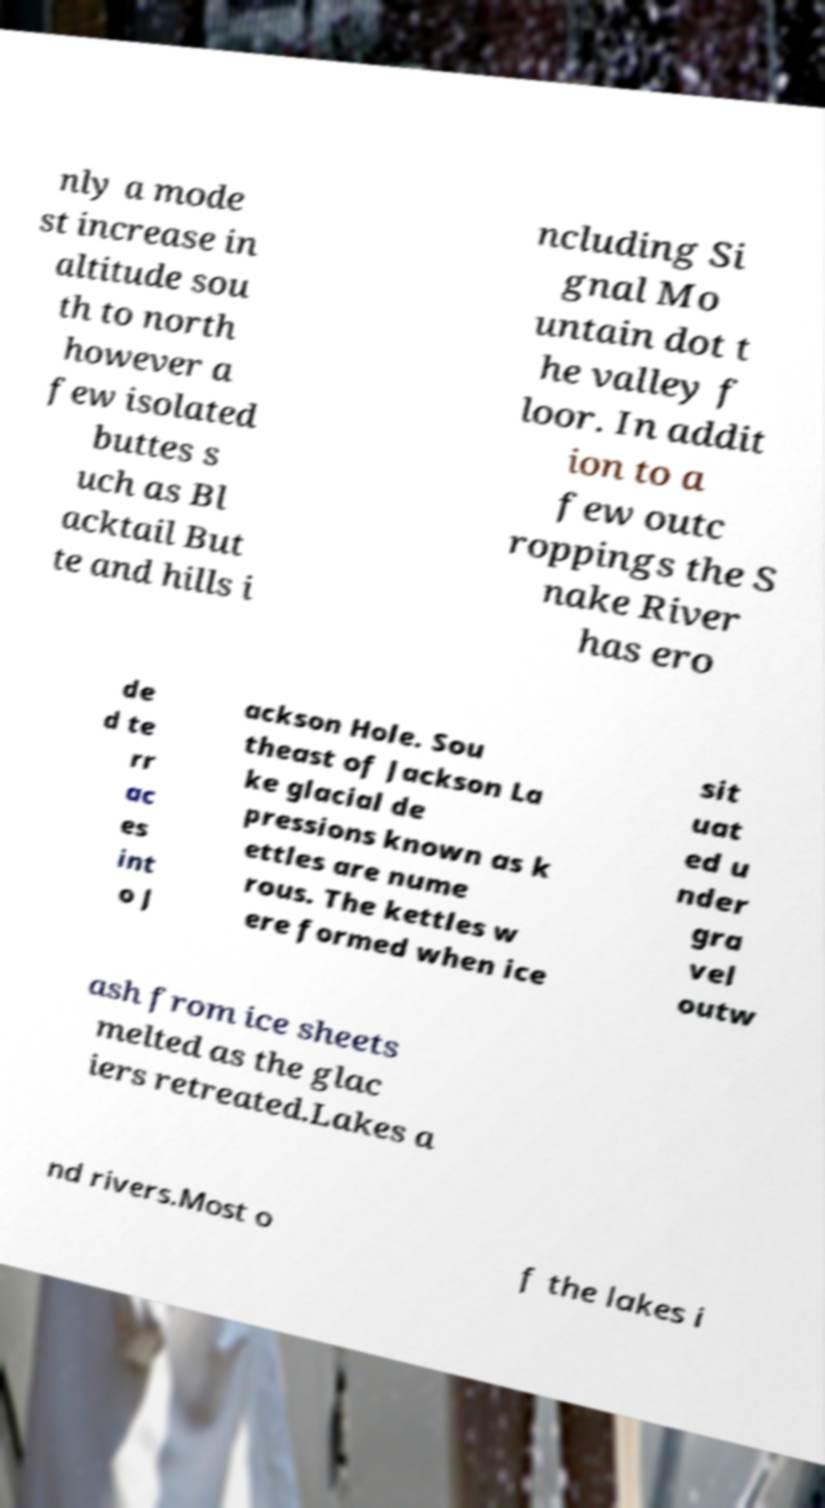Could you assist in decoding the text presented in this image and type it out clearly? nly a mode st increase in altitude sou th to north however a few isolated buttes s uch as Bl acktail But te and hills i ncluding Si gnal Mo untain dot t he valley f loor. In addit ion to a few outc roppings the S nake River has ero de d te rr ac es int o J ackson Hole. Sou theast of Jackson La ke glacial de pressions known as k ettles are nume rous. The kettles w ere formed when ice sit uat ed u nder gra vel outw ash from ice sheets melted as the glac iers retreated.Lakes a nd rivers.Most o f the lakes i 